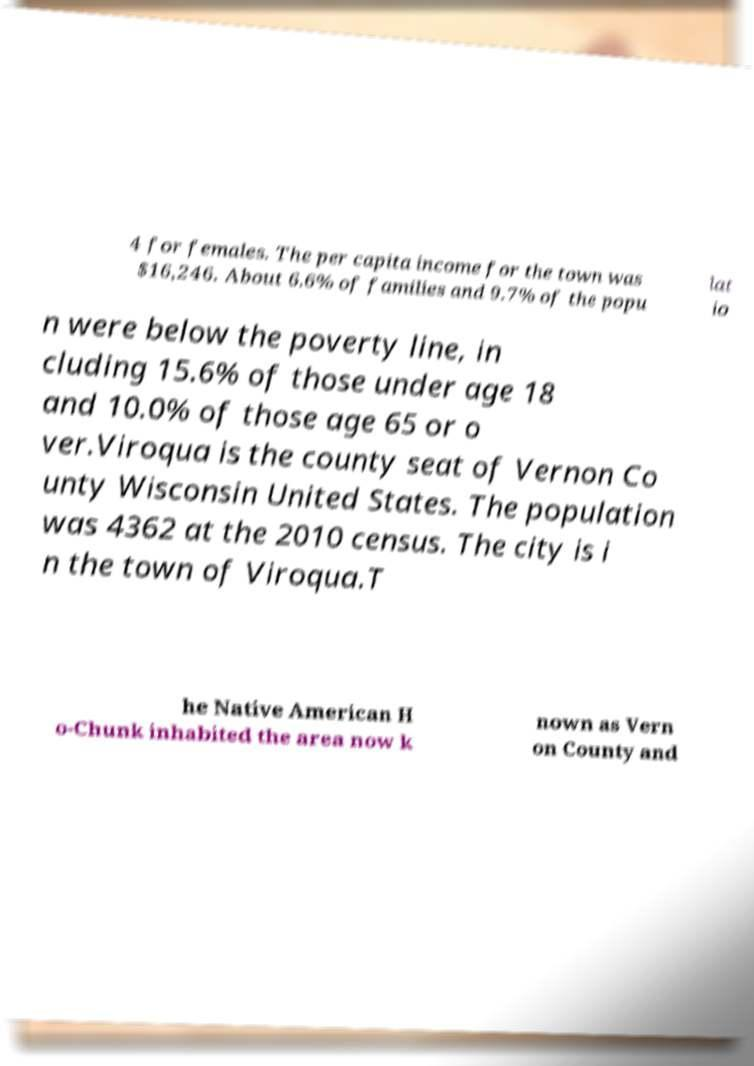For documentation purposes, I need the text within this image transcribed. Could you provide that? 4 for females. The per capita income for the town was $16,246. About 6.6% of families and 9.7% of the popu lat io n were below the poverty line, in cluding 15.6% of those under age 18 and 10.0% of those age 65 or o ver.Viroqua is the county seat of Vernon Co unty Wisconsin United States. The population was 4362 at the 2010 census. The city is i n the town of Viroqua.T he Native American H o-Chunk inhabited the area now k nown as Vern on County and 